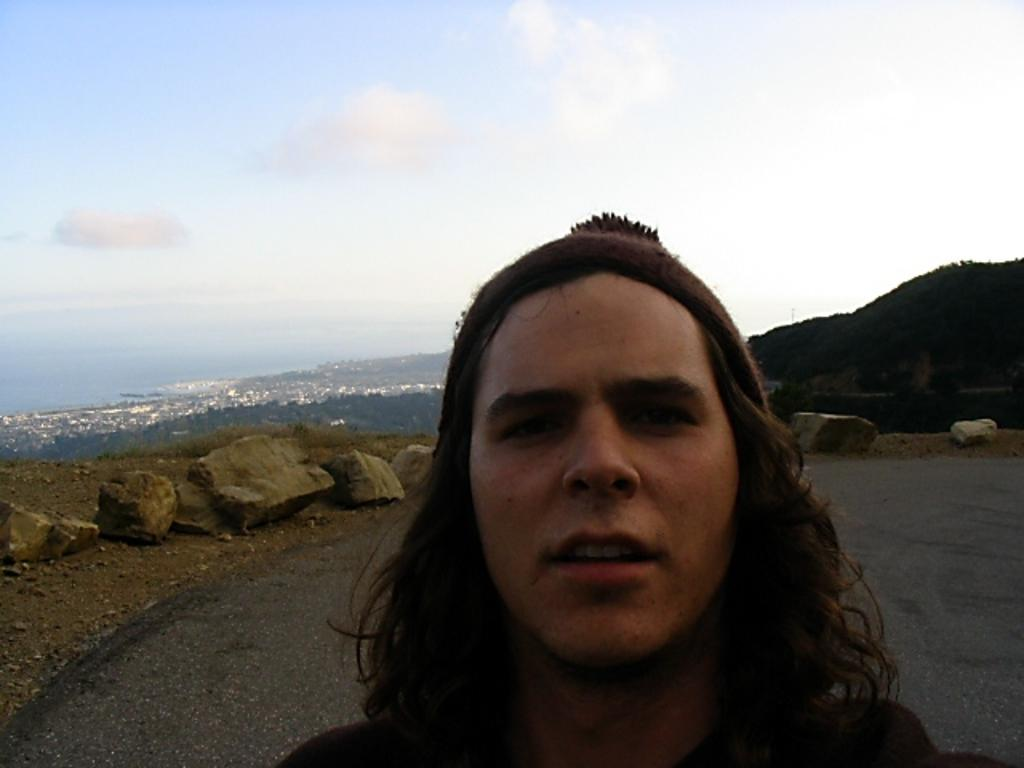What is the main subject in the image? There is a person standing in the image. Can you describe the ground in the background of the image? There are rocks on the ground in the background of the image. How many rabbits can be seen sitting on the table in the image? There are no rabbits or tables present in the image. 